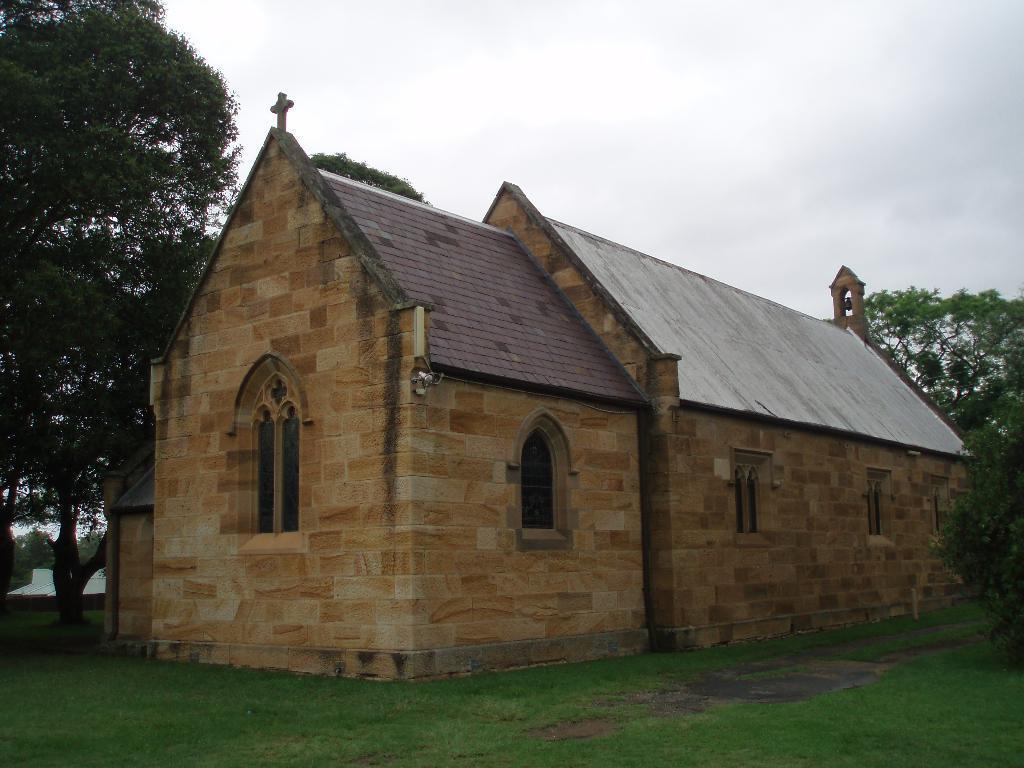How would you summarize this image in a sentence or two? In the image in the front there's grass on the ground. In the center there is a house. In the background there are trees, there is water and the sky is cloudy. 